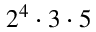<formula> <loc_0><loc_0><loc_500><loc_500>2 ^ { 4 } \cdot 3 \cdot 5</formula> 